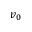Convert formula to latex. <formula><loc_0><loc_0><loc_500><loc_500>v _ { 0 }</formula> 